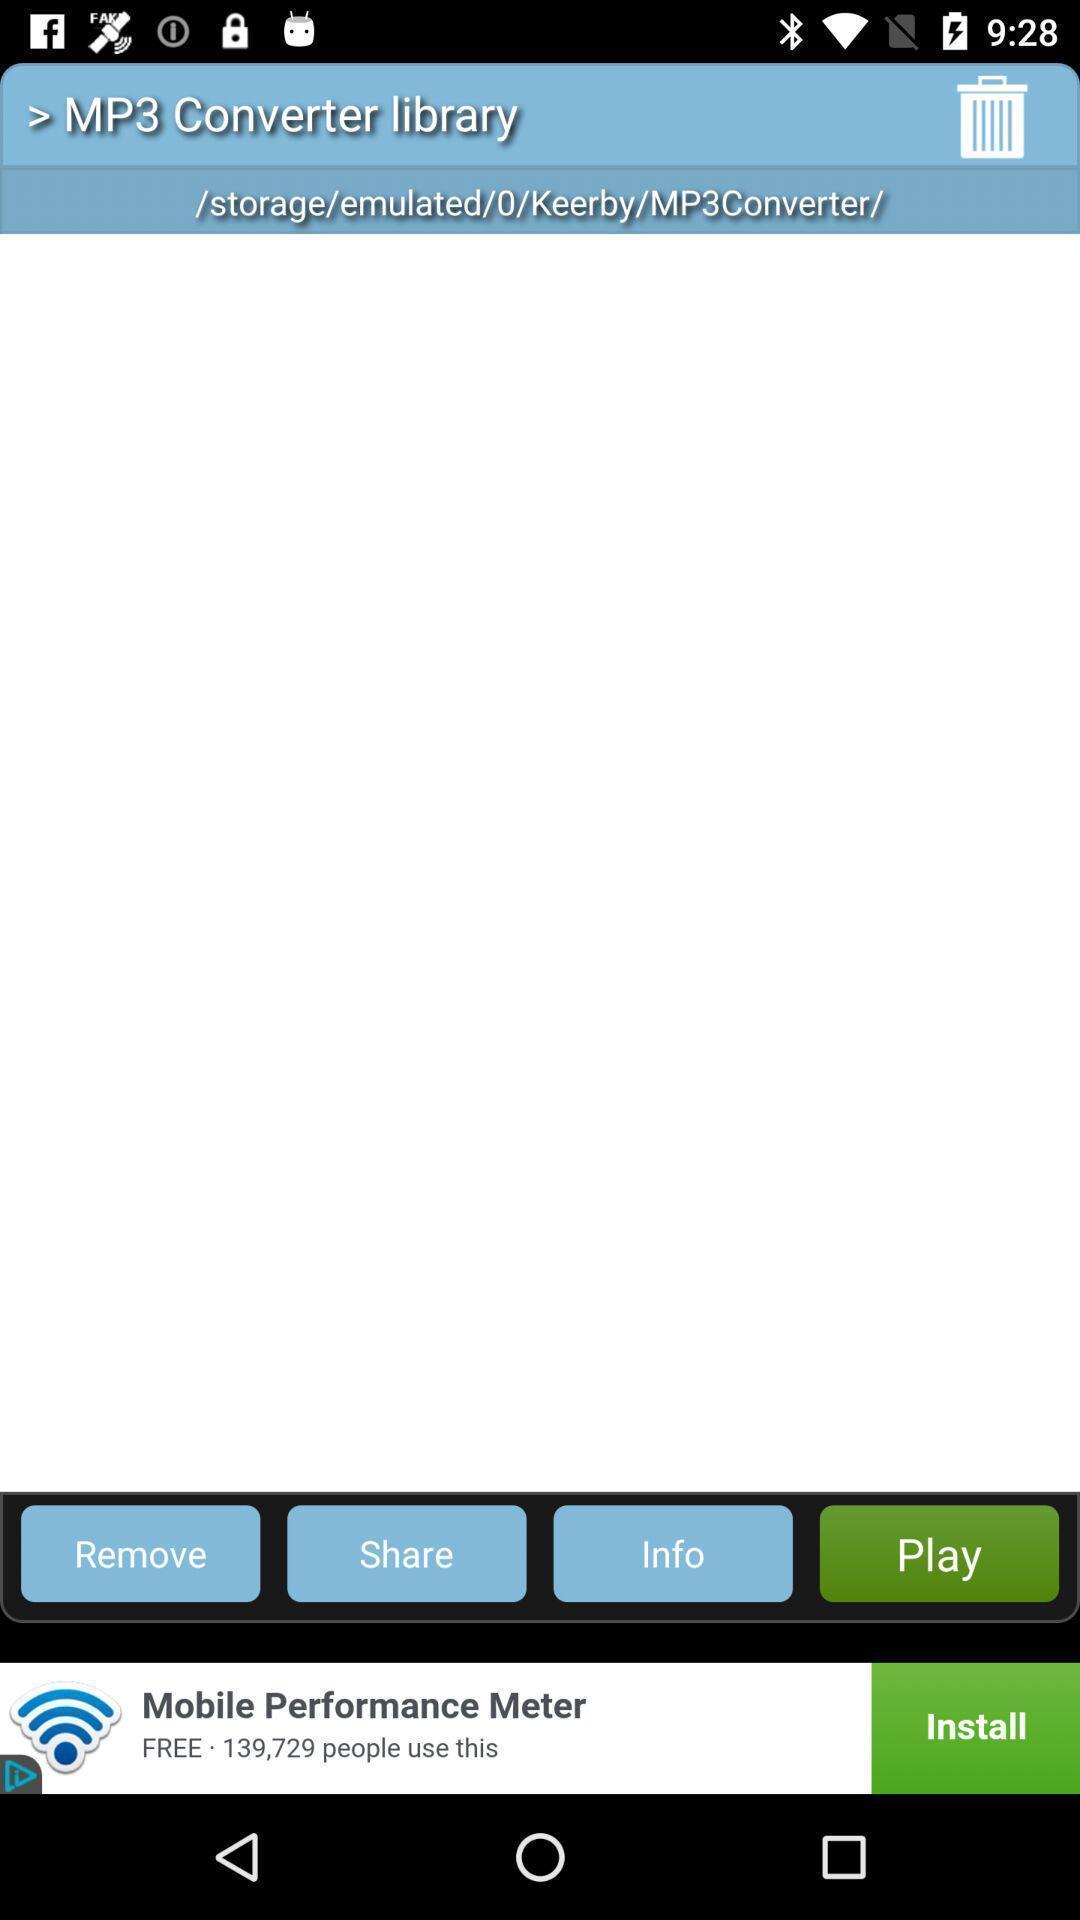Give me a narrative description of this picture. Page showing stored files in the library. 